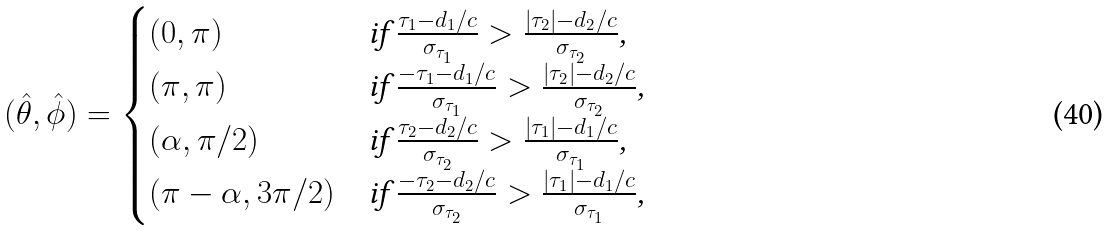<formula> <loc_0><loc_0><loc_500><loc_500>( \hat { \theta } , \hat { \phi } ) = \begin{cases} ( 0 , \pi ) & \text {if $\frac{\tau_{1}-d_{1}/c}{\sigma_{\tau_{1}}} > \frac{|\tau_{2}|-d_{2}/c}{\sigma_{\tau_{2}}}$,} \\ ( \pi , \pi ) & \text {if $\frac{-\tau_{1}-d_{1}/c}{\sigma_{\tau_{1}}} > \frac{|\tau_{2}|-d_{2}/c}{\sigma_{\tau_{2}}}$,} \\ ( \alpha , \pi / 2 ) & \text {if $\frac{\tau_{2}-d_{2}/c}{\sigma_{\tau_{2}}} > \frac{|\tau_{1}|-d_{1}/c}{\sigma_{\tau_{1}}}$,} \\ ( \pi - \alpha , 3 \pi / 2 ) & \text {if $\frac{-\tau_{2}-d_{2}/c}{\sigma_{\tau_{2}}} > \frac{|\tau_{1}|-d_{1}/c}{\sigma_{\tau_{1}}}$,} \\ \end{cases}</formula> 